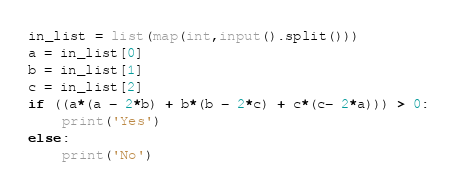Convert code to text. <code><loc_0><loc_0><loc_500><loc_500><_Python_>in_list = list(map(int,input().split()))
a = in_list[0]
b = in_list[1]
c = in_list[2]
if ((a*(a - 2*b) + b*(b - 2*c) + c*(c- 2*a))) > 0:
    print('Yes')
else:
    print('No')</code> 